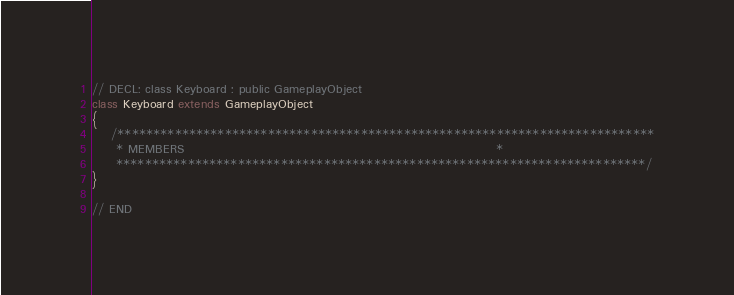<code> <loc_0><loc_0><loc_500><loc_500><_Haxe_>
// DECL: class Keyboard : public GameplayObject
class Keyboard extends GameplayObject
{
    /***************************************************************************
     * MEMBERS                                                                 *
     **************************************************************************/
}

// END
</code> 